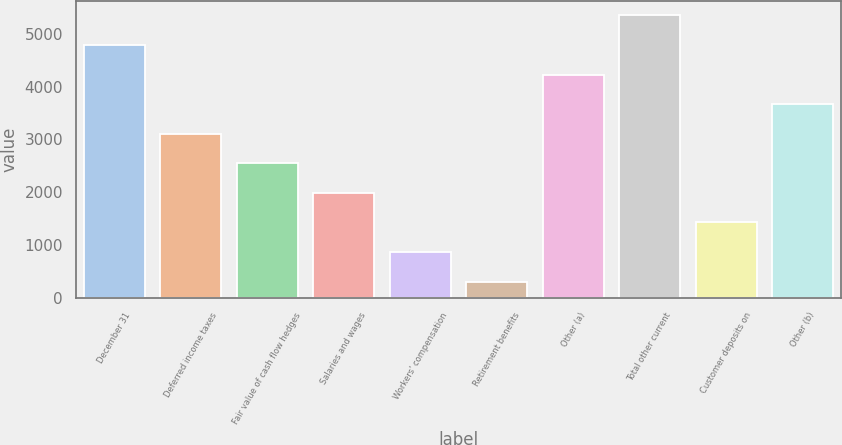Convert chart. <chart><loc_0><loc_0><loc_500><loc_500><bar_chart><fcel>December 31<fcel>Deferred income taxes<fcel>Fair value of cash flow hedges<fcel>Salaries and wages<fcel>Workers' compensation<fcel>Retirement benefits<fcel>Other (a)<fcel>Total other current<fcel>Customer deposits on<fcel>Other (b)<nl><fcel>4793.6<fcel>3110<fcel>2548.8<fcel>1987.6<fcel>865.2<fcel>304<fcel>4232.4<fcel>5354.8<fcel>1426.4<fcel>3671.2<nl></chart> 